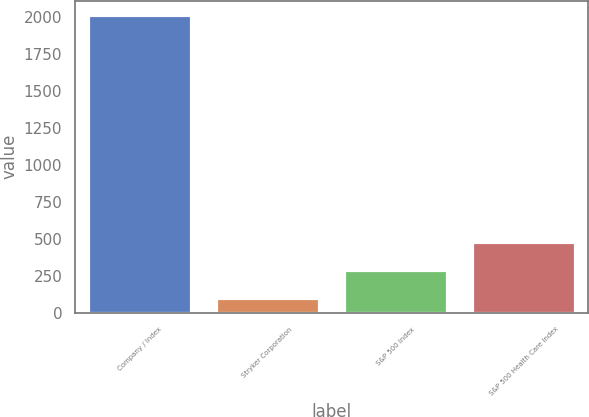Convert chart to OTSL. <chart><loc_0><loc_0><loc_500><loc_500><bar_chart><fcel>Company / Index<fcel>Stryker Corporation<fcel>S&P 500 Index<fcel>S&P 500 Health Care Index<nl><fcel>2010<fcel>100<fcel>291<fcel>482<nl></chart> 